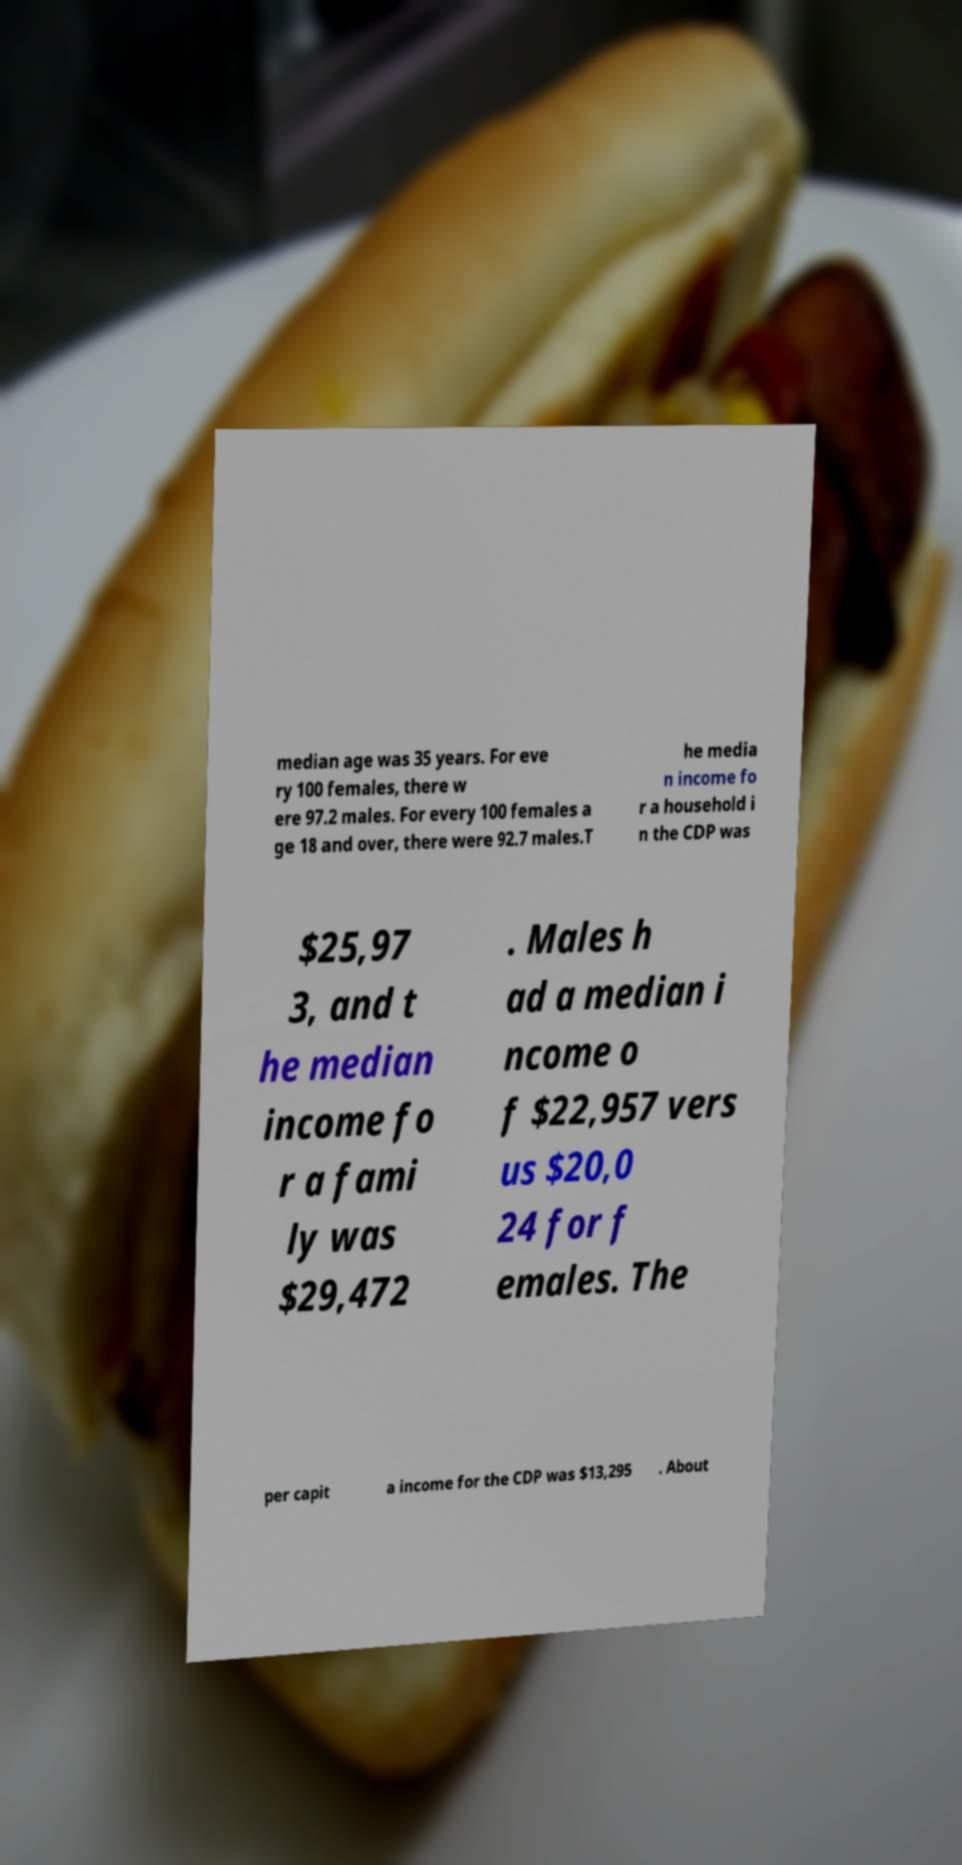For documentation purposes, I need the text within this image transcribed. Could you provide that? median age was 35 years. For eve ry 100 females, there w ere 97.2 males. For every 100 females a ge 18 and over, there were 92.7 males.T he media n income fo r a household i n the CDP was $25,97 3, and t he median income fo r a fami ly was $29,472 . Males h ad a median i ncome o f $22,957 vers us $20,0 24 for f emales. The per capit a income for the CDP was $13,295 . About 